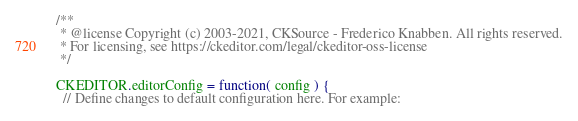<code> <loc_0><loc_0><loc_500><loc_500><_JavaScript_>/**
 * @license Copyright (c) 2003-2021, CKSource - Frederico Knabben. All rights reserved.
 * For licensing, see https://ckeditor.com/legal/ckeditor-oss-license
 */

CKEDITOR.editorConfig = function( config ) {
  // Define changes to default configuration here. For example:</code> 